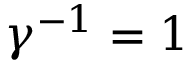Convert formula to latex. <formula><loc_0><loc_0><loc_500><loc_500>\gamma ^ { - 1 } = 1</formula> 